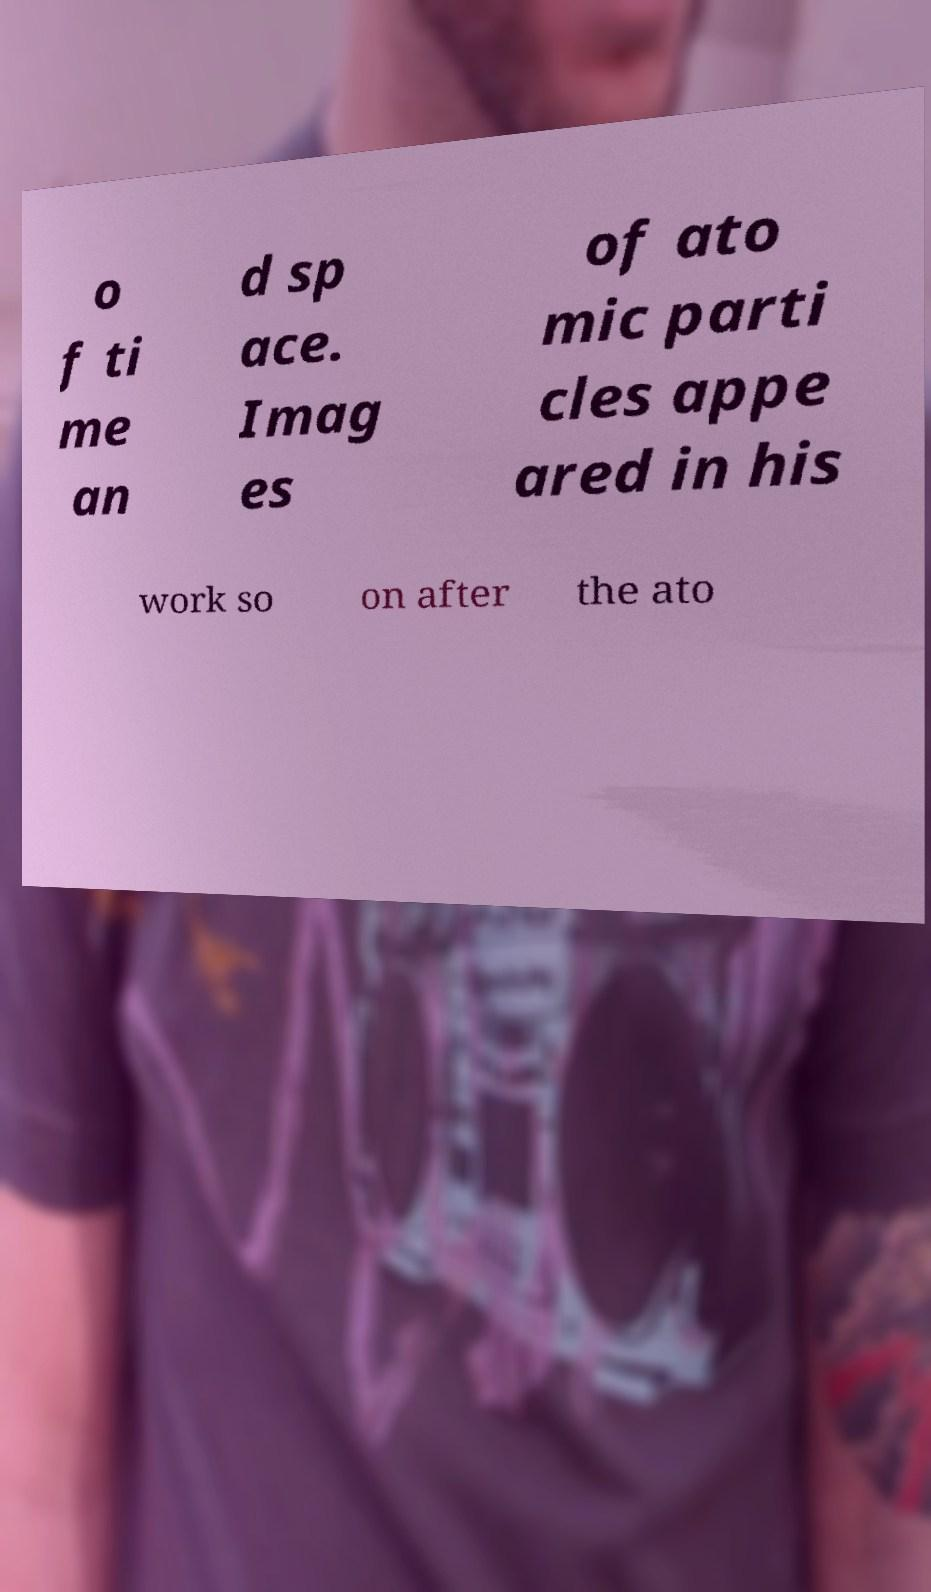Please identify and transcribe the text found in this image. o f ti me an d sp ace. Imag es of ato mic parti cles appe ared in his work so on after the ato 